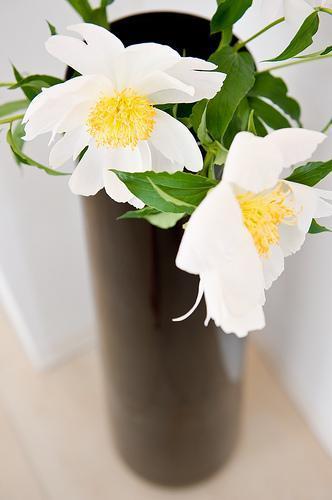How many vases are there?
Give a very brief answer. 1. 